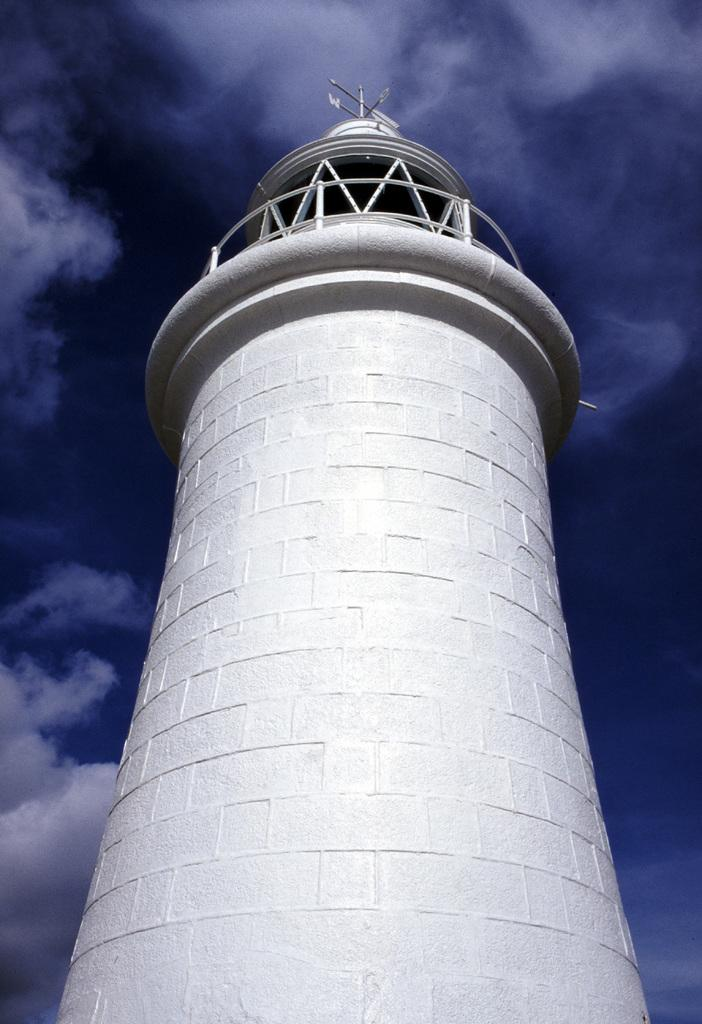What is the main structure in the center of the image? There is a tower in the center of the image. What type of material is used for the rods in the image? The rods in the image are made of metal. Can you describe any other objects in the image besides the tower and metal rods? Yes, there are other objects in the image. What can be seen in the background of the image? The sky is visible in the background of the image. What is the weather like in the image? The presence of clouds in the sky suggests that it might be partly cloudy. Where is the office located in the image? There is no office present in the image. How much was the payment for the tower in the image? There is no information about payment in the image, as it only shows the tower and other objects. 